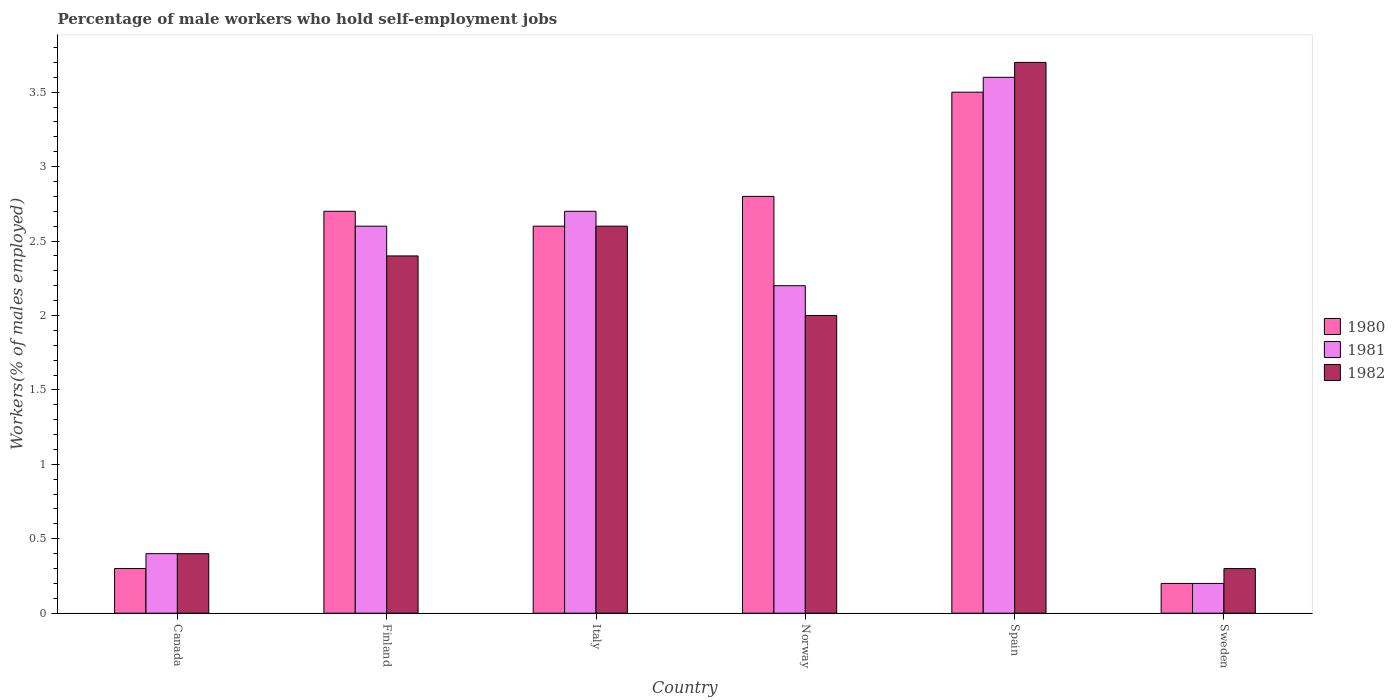How many different coloured bars are there?
Make the answer very short. 3. Are the number of bars on each tick of the X-axis equal?
Provide a short and direct response. Yes. How many bars are there on the 4th tick from the right?
Offer a terse response. 3. In how many cases, is the number of bars for a given country not equal to the number of legend labels?
Provide a succinct answer. 0. What is the percentage of self-employed male workers in 1981 in Finland?
Provide a short and direct response. 2.6. Across all countries, what is the maximum percentage of self-employed male workers in 1982?
Ensure brevity in your answer.  3.7. Across all countries, what is the minimum percentage of self-employed male workers in 1981?
Provide a short and direct response. 0.2. In which country was the percentage of self-employed male workers in 1981 maximum?
Make the answer very short. Spain. What is the total percentage of self-employed male workers in 1981 in the graph?
Provide a succinct answer. 11.7. What is the difference between the percentage of self-employed male workers in 1981 in Italy and that in Spain?
Offer a terse response. -0.9. What is the difference between the percentage of self-employed male workers in 1982 in Italy and the percentage of self-employed male workers in 1980 in Sweden?
Offer a terse response. 2.4. What is the average percentage of self-employed male workers in 1981 per country?
Your answer should be very brief. 1.95. What is the difference between the percentage of self-employed male workers of/in 1980 and percentage of self-employed male workers of/in 1982 in Spain?
Offer a very short reply. -0.2. What is the ratio of the percentage of self-employed male workers in 1980 in Canada to that in Spain?
Provide a short and direct response. 0.09. Is the percentage of self-employed male workers in 1981 in Finland less than that in Norway?
Your answer should be compact. No. What is the difference between the highest and the second highest percentage of self-employed male workers in 1980?
Give a very brief answer. -0.1. What is the difference between the highest and the lowest percentage of self-employed male workers in 1981?
Your answer should be compact. 3.4. In how many countries, is the percentage of self-employed male workers in 1982 greater than the average percentage of self-employed male workers in 1982 taken over all countries?
Your answer should be very brief. 4. How many bars are there?
Make the answer very short. 18. How many countries are there in the graph?
Your response must be concise. 6. Are the values on the major ticks of Y-axis written in scientific E-notation?
Make the answer very short. No. Where does the legend appear in the graph?
Give a very brief answer. Center right. What is the title of the graph?
Offer a very short reply. Percentage of male workers who hold self-employment jobs. What is the label or title of the X-axis?
Your answer should be very brief. Country. What is the label or title of the Y-axis?
Give a very brief answer. Workers(% of males employed). What is the Workers(% of males employed) of 1980 in Canada?
Ensure brevity in your answer.  0.3. What is the Workers(% of males employed) of 1981 in Canada?
Give a very brief answer. 0.4. What is the Workers(% of males employed) in 1982 in Canada?
Offer a terse response. 0.4. What is the Workers(% of males employed) of 1980 in Finland?
Offer a terse response. 2.7. What is the Workers(% of males employed) in 1981 in Finland?
Give a very brief answer. 2.6. What is the Workers(% of males employed) in 1982 in Finland?
Your response must be concise. 2.4. What is the Workers(% of males employed) in 1980 in Italy?
Your response must be concise. 2.6. What is the Workers(% of males employed) of 1981 in Italy?
Offer a terse response. 2.7. What is the Workers(% of males employed) of 1982 in Italy?
Give a very brief answer. 2.6. What is the Workers(% of males employed) of 1980 in Norway?
Ensure brevity in your answer.  2.8. What is the Workers(% of males employed) of 1981 in Norway?
Provide a short and direct response. 2.2. What is the Workers(% of males employed) in 1982 in Norway?
Keep it short and to the point. 2. What is the Workers(% of males employed) of 1981 in Spain?
Make the answer very short. 3.6. What is the Workers(% of males employed) of 1982 in Spain?
Provide a short and direct response. 3.7. What is the Workers(% of males employed) of 1980 in Sweden?
Offer a terse response. 0.2. What is the Workers(% of males employed) of 1981 in Sweden?
Keep it short and to the point. 0.2. What is the Workers(% of males employed) of 1982 in Sweden?
Provide a succinct answer. 0.3. Across all countries, what is the maximum Workers(% of males employed) in 1981?
Give a very brief answer. 3.6. Across all countries, what is the maximum Workers(% of males employed) in 1982?
Ensure brevity in your answer.  3.7. Across all countries, what is the minimum Workers(% of males employed) of 1980?
Make the answer very short. 0.2. Across all countries, what is the minimum Workers(% of males employed) of 1981?
Provide a short and direct response. 0.2. Across all countries, what is the minimum Workers(% of males employed) in 1982?
Keep it short and to the point. 0.3. What is the total Workers(% of males employed) of 1980 in the graph?
Your answer should be very brief. 12.1. What is the difference between the Workers(% of males employed) of 1980 in Canada and that in Italy?
Offer a very short reply. -2.3. What is the difference between the Workers(% of males employed) of 1982 in Canada and that in Italy?
Your response must be concise. -2.2. What is the difference between the Workers(% of males employed) of 1981 in Canada and that in Norway?
Offer a very short reply. -1.8. What is the difference between the Workers(% of males employed) of 1981 in Canada and that in Spain?
Provide a short and direct response. -3.2. What is the difference between the Workers(% of males employed) in 1980 in Canada and that in Sweden?
Offer a terse response. 0.1. What is the difference between the Workers(% of males employed) in 1982 in Canada and that in Sweden?
Keep it short and to the point. 0.1. What is the difference between the Workers(% of males employed) in 1982 in Finland and that in Italy?
Make the answer very short. -0.2. What is the difference between the Workers(% of males employed) of 1981 in Finland and that in Norway?
Provide a short and direct response. 0.4. What is the difference between the Workers(% of males employed) of 1980 in Finland and that in Spain?
Your response must be concise. -0.8. What is the difference between the Workers(% of males employed) in 1982 in Finland and that in Spain?
Your answer should be very brief. -1.3. What is the difference between the Workers(% of males employed) of 1980 in Finland and that in Sweden?
Keep it short and to the point. 2.5. What is the difference between the Workers(% of males employed) of 1981 in Italy and that in Spain?
Keep it short and to the point. -0.9. What is the difference between the Workers(% of males employed) of 1982 in Italy and that in Spain?
Keep it short and to the point. -1.1. What is the difference between the Workers(% of males employed) of 1980 in Italy and that in Sweden?
Your answer should be compact. 2.4. What is the difference between the Workers(% of males employed) of 1982 in Italy and that in Sweden?
Offer a very short reply. 2.3. What is the difference between the Workers(% of males employed) in 1981 in Norway and that in Spain?
Ensure brevity in your answer.  -1.4. What is the difference between the Workers(% of males employed) of 1982 in Norway and that in Spain?
Your answer should be compact. -1.7. What is the difference between the Workers(% of males employed) in 1981 in Norway and that in Sweden?
Offer a very short reply. 2. What is the difference between the Workers(% of males employed) in 1982 in Norway and that in Sweden?
Offer a very short reply. 1.7. What is the difference between the Workers(% of males employed) in 1981 in Spain and that in Sweden?
Ensure brevity in your answer.  3.4. What is the difference between the Workers(% of males employed) in 1982 in Spain and that in Sweden?
Give a very brief answer. 3.4. What is the difference between the Workers(% of males employed) in 1980 in Canada and the Workers(% of males employed) in 1982 in Finland?
Your answer should be very brief. -2.1. What is the difference between the Workers(% of males employed) of 1980 in Canada and the Workers(% of males employed) of 1982 in Norway?
Provide a short and direct response. -1.7. What is the difference between the Workers(% of males employed) in 1980 in Canada and the Workers(% of males employed) in 1982 in Spain?
Your answer should be compact. -3.4. What is the difference between the Workers(% of males employed) of 1981 in Finland and the Workers(% of males employed) of 1982 in Italy?
Keep it short and to the point. 0. What is the difference between the Workers(% of males employed) in 1980 in Finland and the Workers(% of males employed) in 1981 in Norway?
Your answer should be very brief. 0.5. What is the difference between the Workers(% of males employed) in 1980 in Finland and the Workers(% of males employed) in 1982 in Norway?
Provide a short and direct response. 0.7. What is the difference between the Workers(% of males employed) in 1980 in Finland and the Workers(% of males employed) in 1981 in Spain?
Your answer should be compact. -0.9. What is the difference between the Workers(% of males employed) in 1981 in Finland and the Workers(% of males employed) in 1982 in Spain?
Ensure brevity in your answer.  -1.1. What is the difference between the Workers(% of males employed) in 1980 in Finland and the Workers(% of males employed) in 1981 in Sweden?
Ensure brevity in your answer.  2.5. What is the difference between the Workers(% of males employed) in 1980 in Finland and the Workers(% of males employed) in 1982 in Sweden?
Make the answer very short. 2.4. What is the difference between the Workers(% of males employed) of 1981 in Italy and the Workers(% of males employed) of 1982 in Norway?
Give a very brief answer. 0.7. What is the difference between the Workers(% of males employed) of 1980 in Italy and the Workers(% of males employed) of 1981 in Spain?
Your answer should be compact. -1. What is the difference between the Workers(% of males employed) in 1980 in Italy and the Workers(% of males employed) in 1982 in Sweden?
Provide a succinct answer. 2.3. What is the difference between the Workers(% of males employed) in 1981 in Italy and the Workers(% of males employed) in 1982 in Sweden?
Make the answer very short. 2.4. What is the difference between the Workers(% of males employed) in 1980 in Norway and the Workers(% of males employed) in 1982 in Spain?
Offer a very short reply. -0.9. What is the difference between the Workers(% of males employed) of 1981 in Norway and the Workers(% of males employed) of 1982 in Spain?
Your answer should be compact. -1.5. What is the difference between the Workers(% of males employed) of 1980 in Norway and the Workers(% of males employed) of 1981 in Sweden?
Your answer should be very brief. 2.6. What is the difference between the Workers(% of males employed) of 1981 in Norway and the Workers(% of males employed) of 1982 in Sweden?
Ensure brevity in your answer.  1.9. What is the difference between the Workers(% of males employed) of 1980 in Spain and the Workers(% of males employed) of 1982 in Sweden?
Your answer should be compact. 3.2. What is the difference between the Workers(% of males employed) in 1981 in Spain and the Workers(% of males employed) in 1982 in Sweden?
Give a very brief answer. 3.3. What is the average Workers(% of males employed) of 1980 per country?
Your response must be concise. 2.02. What is the average Workers(% of males employed) of 1981 per country?
Your response must be concise. 1.95. What is the difference between the Workers(% of males employed) in 1980 and Workers(% of males employed) in 1981 in Canada?
Make the answer very short. -0.1. What is the difference between the Workers(% of males employed) in 1980 and Workers(% of males employed) in 1982 in Canada?
Keep it short and to the point. -0.1. What is the difference between the Workers(% of males employed) in 1981 and Workers(% of males employed) in 1982 in Canada?
Provide a short and direct response. 0. What is the difference between the Workers(% of males employed) of 1980 and Workers(% of males employed) of 1981 in Finland?
Provide a short and direct response. 0.1. What is the difference between the Workers(% of males employed) in 1980 and Workers(% of males employed) in 1982 in Italy?
Provide a short and direct response. 0. What is the difference between the Workers(% of males employed) in 1980 and Workers(% of males employed) in 1981 in Norway?
Your answer should be very brief. 0.6. What is the difference between the Workers(% of males employed) in 1981 and Workers(% of males employed) in 1982 in Norway?
Offer a terse response. 0.2. What is the difference between the Workers(% of males employed) of 1981 and Workers(% of males employed) of 1982 in Spain?
Keep it short and to the point. -0.1. What is the difference between the Workers(% of males employed) in 1981 and Workers(% of males employed) in 1982 in Sweden?
Keep it short and to the point. -0.1. What is the ratio of the Workers(% of males employed) of 1981 in Canada to that in Finland?
Keep it short and to the point. 0.15. What is the ratio of the Workers(% of males employed) of 1982 in Canada to that in Finland?
Keep it short and to the point. 0.17. What is the ratio of the Workers(% of males employed) in 1980 in Canada to that in Italy?
Ensure brevity in your answer.  0.12. What is the ratio of the Workers(% of males employed) of 1981 in Canada to that in Italy?
Your answer should be compact. 0.15. What is the ratio of the Workers(% of males employed) in 1982 in Canada to that in Italy?
Your answer should be very brief. 0.15. What is the ratio of the Workers(% of males employed) of 1980 in Canada to that in Norway?
Your answer should be compact. 0.11. What is the ratio of the Workers(% of males employed) of 1981 in Canada to that in Norway?
Keep it short and to the point. 0.18. What is the ratio of the Workers(% of males employed) of 1982 in Canada to that in Norway?
Provide a succinct answer. 0.2. What is the ratio of the Workers(% of males employed) of 1980 in Canada to that in Spain?
Offer a very short reply. 0.09. What is the ratio of the Workers(% of males employed) in 1981 in Canada to that in Spain?
Your answer should be compact. 0.11. What is the ratio of the Workers(% of males employed) in 1982 in Canada to that in Spain?
Make the answer very short. 0.11. What is the ratio of the Workers(% of males employed) in 1980 in Canada to that in Sweden?
Your answer should be very brief. 1.5. What is the ratio of the Workers(% of males employed) of 1981 in Canada to that in Sweden?
Your answer should be compact. 2. What is the ratio of the Workers(% of males employed) in 1982 in Canada to that in Sweden?
Make the answer very short. 1.33. What is the ratio of the Workers(% of males employed) of 1981 in Finland to that in Norway?
Your response must be concise. 1.18. What is the ratio of the Workers(% of males employed) of 1980 in Finland to that in Spain?
Your answer should be compact. 0.77. What is the ratio of the Workers(% of males employed) of 1981 in Finland to that in Spain?
Your response must be concise. 0.72. What is the ratio of the Workers(% of males employed) of 1982 in Finland to that in Spain?
Provide a short and direct response. 0.65. What is the ratio of the Workers(% of males employed) of 1981 in Finland to that in Sweden?
Keep it short and to the point. 13. What is the ratio of the Workers(% of males employed) in 1982 in Finland to that in Sweden?
Offer a terse response. 8. What is the ratio of the Workers(% of males employed) in 1980 in Italy to that in Norway?
Your answer should be very brief. 0.93. What is the ratio of the Workers(% of males employed) of 1981 in Italy to that in Norway?
Make the answer very short. 1.23. What is the ratio of the Workers(% of males employed) in 1982 in Italy to that in Norway?
Offer a terse response. 1.3. What is the ratio of the Workers(% of males employed) in 1980 in Italy to that in Spain?
Make the answer very short. 0.74. What is the ratio of the Workers(% of males employed) of 1982 in Italy to that in Spain?
Make the answer very short. 0.7. What is the ratio of the Workers(% of males employed) of 1980 in Italy to that in Sweden?
Offer a terse response. 13. What is the ratio of the Workers(% of males employed) of 1982 in Italy to that in Sweden?
Give a very brief answer. 8.67. What is the ratio of the Workers(% of males employed) in 1981 in Norway to that in Spain?
Offer a very short reply. 0.61. What is the ratio of the Workers(% of males employed) in 1982 in Norway to that in Spain?
Your answer should be compact. 0.54. What is the ratio of the Workers(% of males employed) of 1981 in Norway to that in Sweden?
Your answer should be very brief. 11. What is the ratio of the Workers(% of males employed) in 1982 in Spain to that in Sweden?
Provide a short and direct response. 12.33. What is the difference between the highest and the second highest Workers(% of males employed) of 1981?
Your answer should be very brief. 0.9. What is the difference between the highest and the lowest Workers(% of males employed) in 1981?
Offer a very short reply. 3.4. 